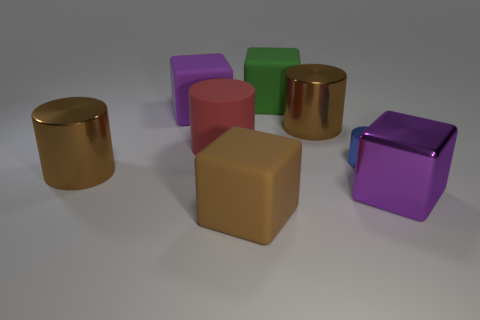Is the number of red matte things behind the matte cylinder less than the number of green objects to the right of the large green rubber object?
Provide a short and direct response. No. What number of objects are either gray rubber spheres or large purple cubes?
Your answer should be compact. 2. What number of brown metal things are behind the blue metal object?
Ensure brevity in your answer.  1. What shape is the big red object that is the same material as the green object?
Your answer should be compact. Cylinder. There is a brown metal object behind the big red cylinder; is it the same shape as the big red thing?
Your response must be concise. Yes. What number of cyan objects are large objects or large matte blocks?
Keep it short and to the point. 0. Are there an equal number of large metallic cylinders that are left of the big brown block and metallic blocks that are behind the purple metallic cube?
Provide a succinct answer. No. The rubber cylinder that is in front of the brown thing behind the large cylinder that is on the left side of the red cylinder is what color?
Make the answer very short. Red. Are there any other things of the same color as the large rubber cylinder?
Provide a short and direct response. No. What is the size of the cube that is in front of the large purple metallic thing?
Give a very brief answer. Large. 